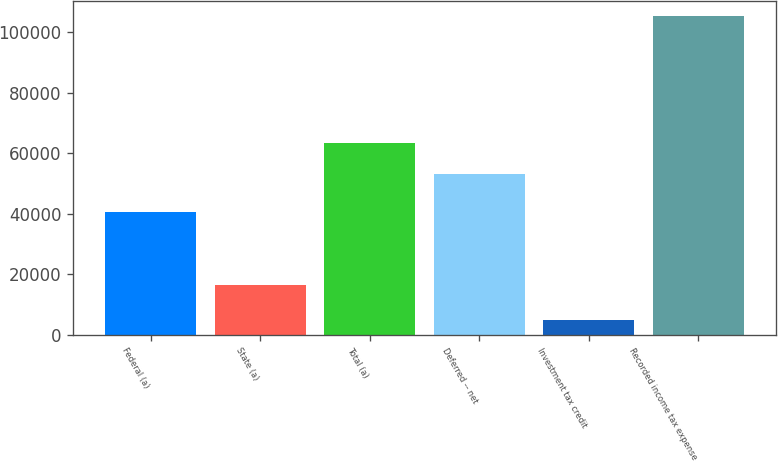<chart> <loc_0><loc_0><loc_500><loc_500><bar_chart><fcel>Federal (a)<fcel>State (a)<fcel>Total (a)<fcel>Deferred -- net<fcel>Investment tax credit<fcel>Recorded income tax expense<nl><fcel>40632<fcel>16306<fcel>63343.5<fcel>53309<fcel>4951<fcel>105296<nl></chart> 